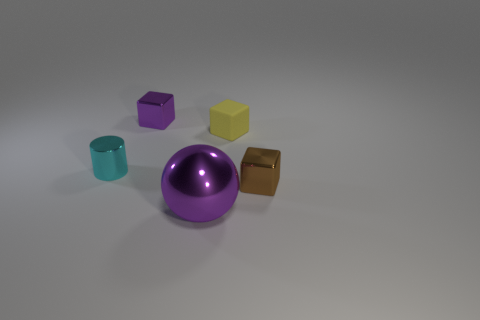Subtract all shiny cubes. How many cubes are left? 1 Add 2 big brown cubes. How many objects exist? 7 Subtract all brown blocks. How many blocks are left? 2 Subtract 1 balls. How many balls are left? 0 Subtract all large purple metal things. Subtract all small cubes. How many objects are left? 1 Add 4 matte cubes. How many matte cubes are left? 5 Add 1 cyan cylinders. How many cyan cylinders exist? 2 Subtract 0 red spheres. How many objects are left? 5 Subtract all spheres. How many objects are left? 4 Subtract all brown cylinders. Subtract all gray cubes. How many cylinders are left? 1 